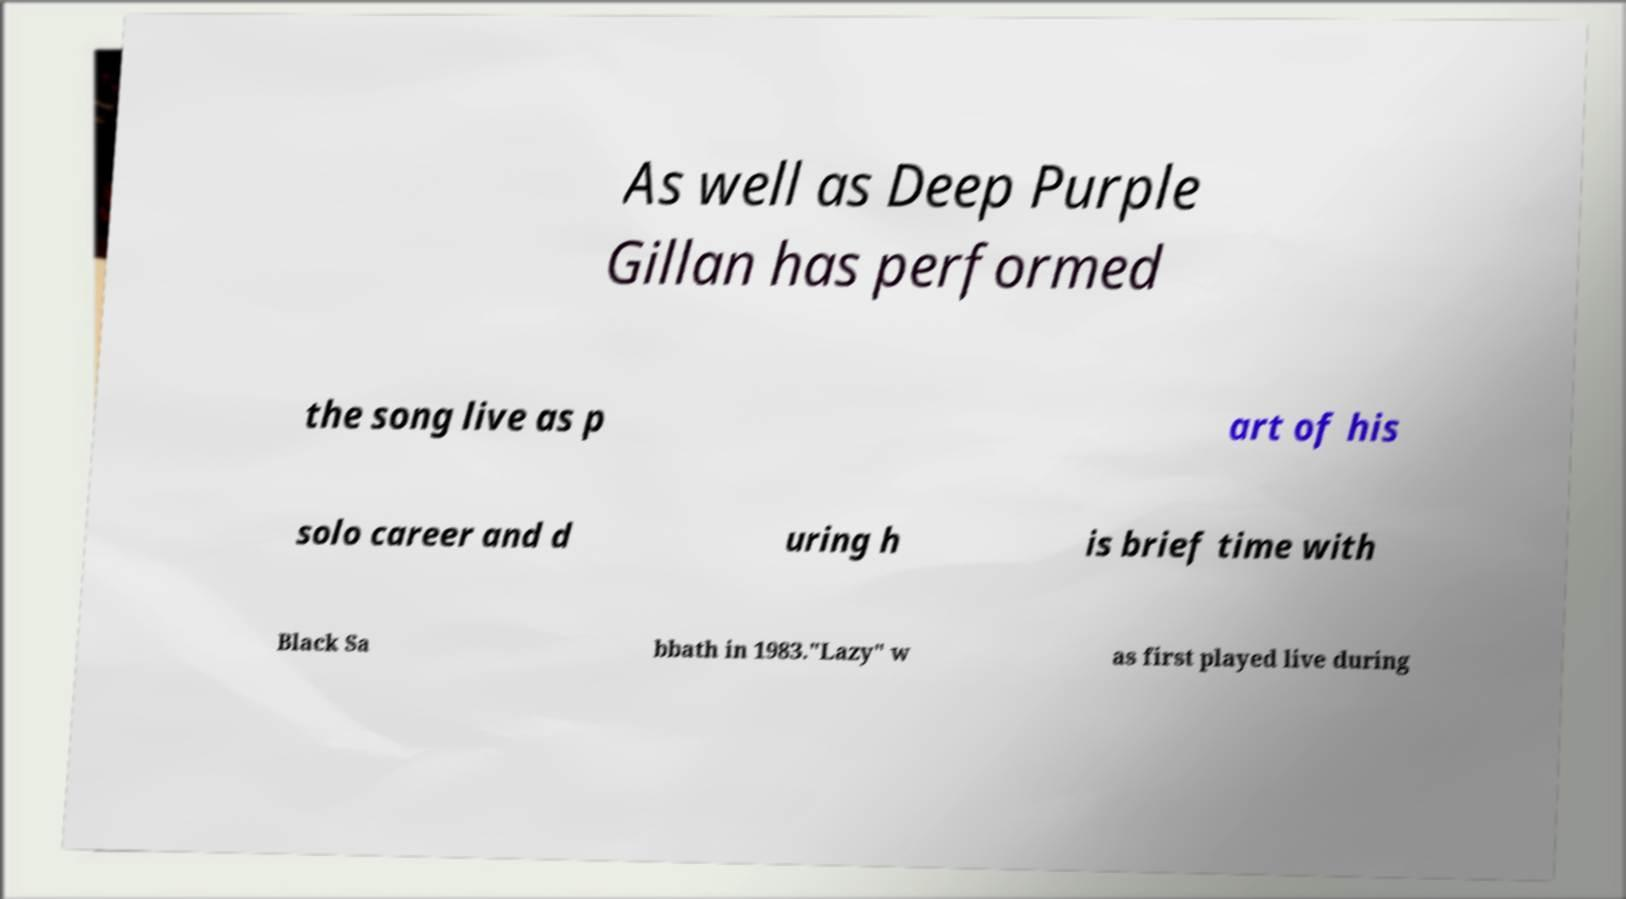There's text embedded in this image that I need extracted. Can you transcribe it verbatim? As well as Deep Purple Gillan has performed the song live as p art of his solo career and d uring h is brief time with Black Sa bbath in 1983."Lazy" w as first played live during 